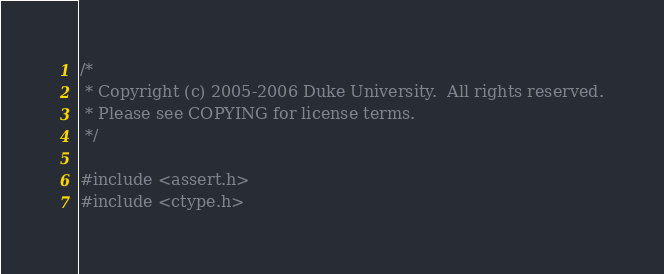Convert code to text. <code><loc_0><loc_0><loc_500><loc_500><_C++_>/*
 * Copyright (c) 2005-2006 Duke University.  All rights reserved.
 * Please see COPYING for license terms.
 */

#include <assert.h>
#include <ctype.h></code> 